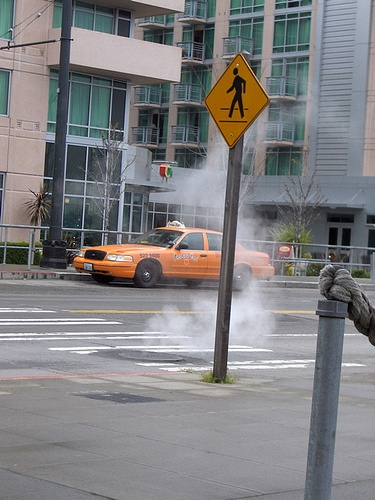Describe the objects in this image and their specific colors. I can see a car in teal, darkgray, gray, salmon, and lightpink tones in this image. 